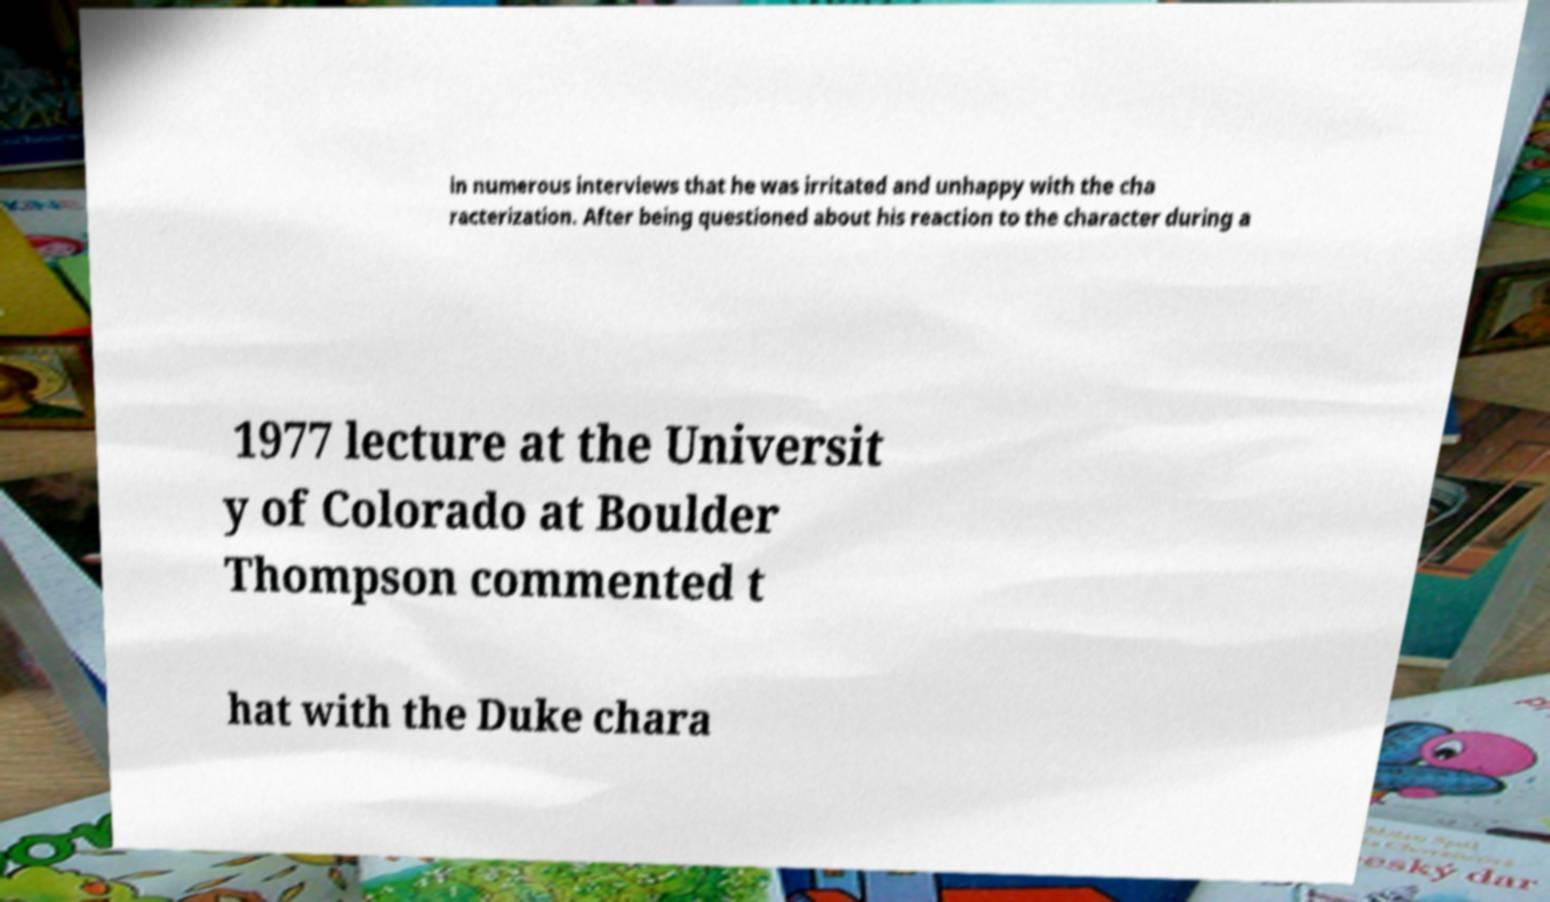Can you read and provide the text displayed in the image?This photo seems to have some interesting text. Can you extract and type it out for me? in numerous interviews that he was irritated and unhappy with the cha racterization. After being questioned about his reaction to the character during a 1977 lecture at the Universit y of Colorado at Boulder Thompson commented t hat with the Duke chara 